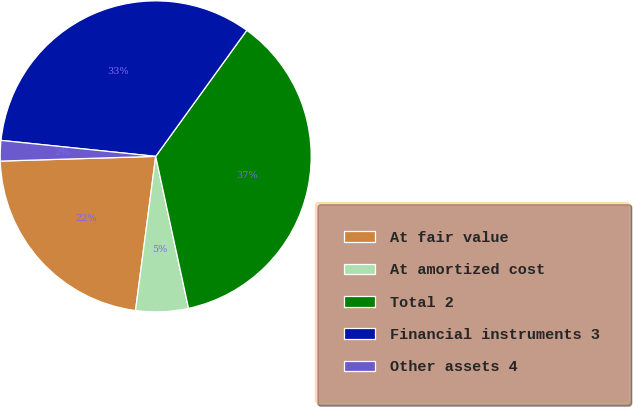<chart> <loc_0><loc_0><loc_500><loc_500><pie_chart><fcel>At fair value<fcel>At amortized cost<fcel>Total 2<fcel>Financial instruments 3<fcel>Other assets 4<nl><fcel>22.44%<fcel>5.46%<fcel>36.65%<fcel>33.32%<fcel>2.12%<nl></chart> 